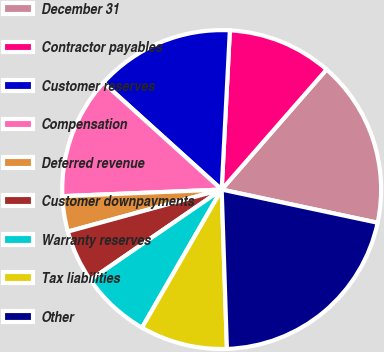<chart> <loc_0><loc_0><loc_500><loc_500><pie_chart><fcel>December 31<fcel>Contractor payables<fcel>Customer reserves<fcel>Compensation<fcel>Deferred revenue<fcel>Customer downpayments<fcel>Warranty reserves<fcel>Tax liabilities<fcel>Other<nl><fcel>16.91%<fcel>10.61%<fcel>14.12%<fcel>12.36%<fcel>3.58%<fcel>5.34%<fcel>7.09%<fcel>8.85%<fcel>21.14%<nl></chart> 